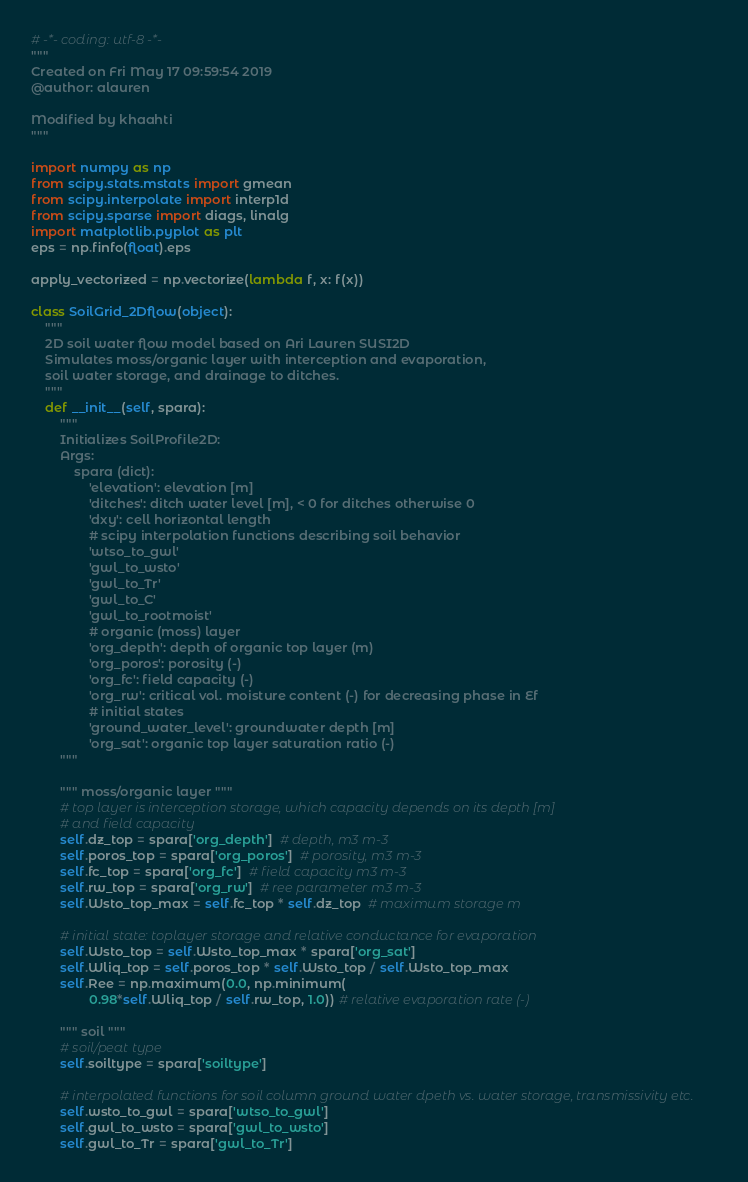<code> <loc_0><loc_0><loc_500><loc_500><_Python_># -*- coding: utf-8 -*-
"""
Created on Fri May 17 09:59:54 2019
@author: alauren

Modified by khaahti
"""

import numpy as np
from scipy.stats.mstats import gmean
from scipy.interpolate import interp1d
from scipy.sparse import diags, linalg
import matplotlib.pyplot as plt
eps = np.finfo(float).eps

apply_vectorized = np.vectorize(lambda f, x: f(x))

class SoilGrid_2Dflow(object):
    """
    2D soil water flow model based on Ari Lauren SUSI2D
    Simulates moss/organic layer with interception and evaporation,
    soil water storage, and drainage to ditches.
    """
    def __init__(self, spara):
        """
        Initializes SoilProfile2D:
        Args:
            spara (dict):
                'elevation': elevation [m]
                'ditches': ditch water level [m], < 0 for ditches otherwise 0
                'dxy': cell horizontal length
                # scipy interpolation functions describing soil behavior
                'wtso_to_gwl'
                'gwl_to_wsto'
                'gwl_to_Tr'
                'gwl_to_C'
                'gwl_to_rootmoist'
                # organic (moss) layer
                'org_depth': depth of organic top layer (m)
                'org_poros': porosity (-)
                'org_fc': field capacity (-)
                'org_rw': critical vol. moisture content (-) for decreasing phase in Ef
                # initial states
                'ground_water_level': groundwater depth [m]
                'org_sat': organic top layer saturation ratio (-)
        """

        """ moss/organic layer """
        # top layer is interception storage, which capacity depends on its depth [m]
        # and field capacity
        self.dz_top = spara['org_depth']  # depth, m3 m-3
        self.poros_top = spara['org_poros']  # porosity, m3 m-3
        self.fc_top = spara['org_fc']  # field capacity m3 m-3
        self.rw_top = spara['org_rw']  # ree parameter m3 m-3
        self.Wsto_top_max = self.fc_top * self.dz_top  # maximum storage m

        # initial state: toplayer storage and relative conductance for evaporation
        self.Wsto_top = self.Wsto_top_max * spara['org_sat']
        self.Wliq_top = self.poros_top * self.Wsto_top / self.Wsto_top_max
        self.Ree = np.maximum(0.0, np.minimum(
                0.98*self.Wliq_top / self.rw_top, 1.0)) # relative evaporation rate (-)

        """ soil """
        # soil/peat type
        self.soiltype = spara['soiltype']

        # interpolated functions for soil column ground water dpeth vs. water storage, transmissivity etc.
        self.wsto_to_gwl = spara['wtso_to_gwl']
        self.gwl_to_wsto = spara['gwl_to_wsto']
        self.gwl_to_Tr = spara['gwl_to_Tr']</code> 